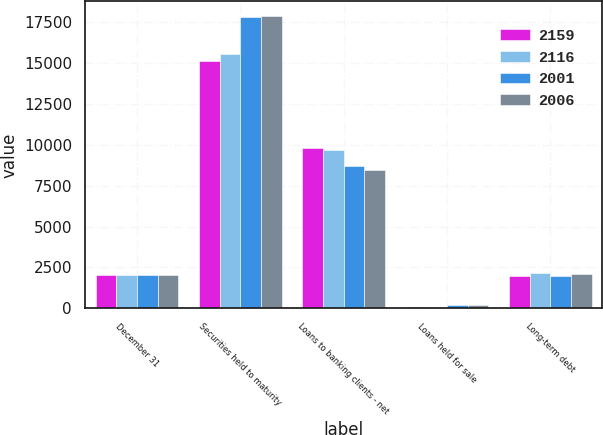<chart> <loc_0><loc_0><loc_500><loc_500><stacked_bar_chart><ecel><fcel>December 31<fcel>Securities held to maturity<fcel>Loans to banking clients - net<fcel>Loans held for sale<fcel>Long-term debt<nl><fcel>2159<fcel>2011<fcel>15108<fcel>9812<fcel>70<fcel>2001<nl><fcel>2116<fcel>2011<fcel>15539<fcel>9671<fcel>73<fcel>2159<nl><fcel>2001<fcel>2010<fcel>17762<fcel>8725<fcel>185<fcel>2006<nl><fcel>2006<fcel>2010<fcel>17848<fcel>8469<fcel>194<fcel>2116<nl></chart> 